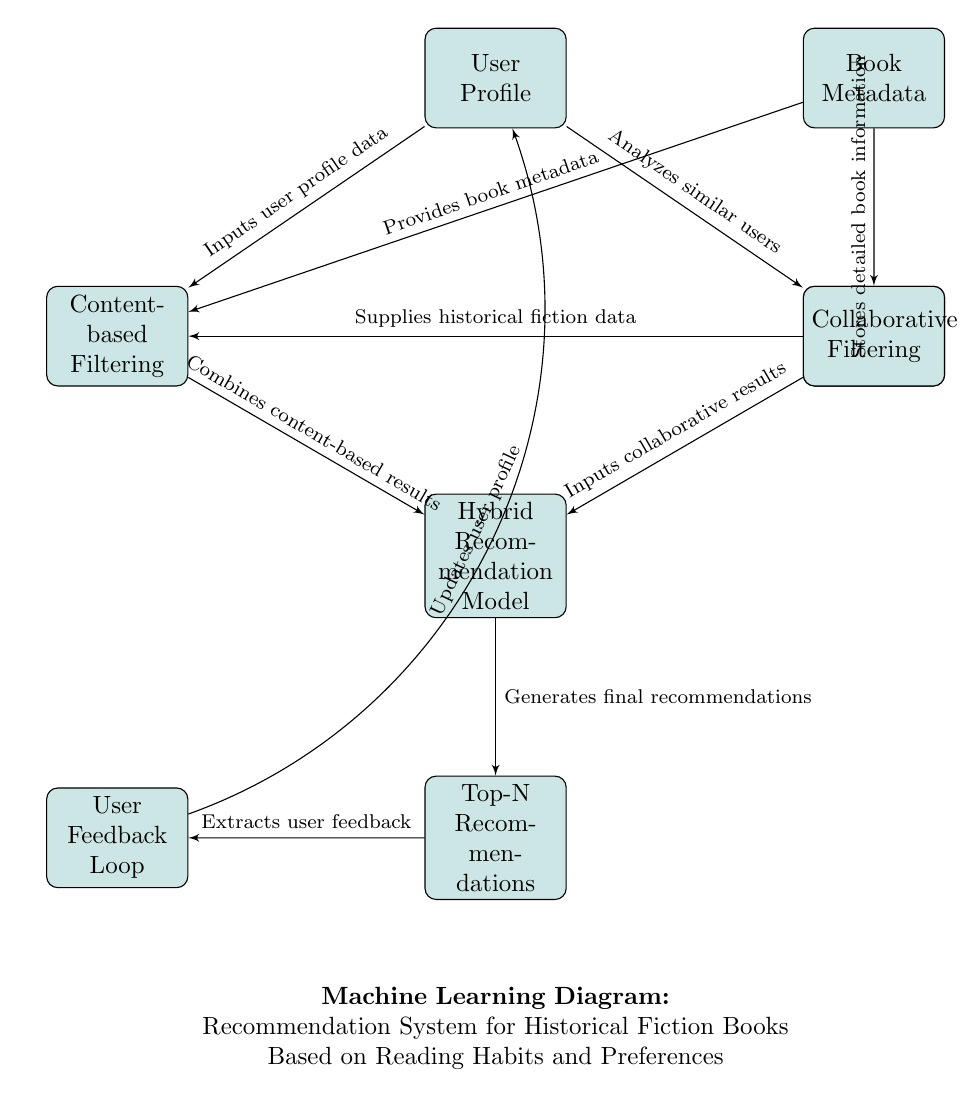What is the first node in the diagram? The first node is labeled "User Profile," indicating where the system begins by taking user-related information as input.
Answer: User Profile How many nodes are there in total? By counting all the distinct blocks in the diagram, we can see there are 7 nodes: User Profile, Book Metadata, Historical Fiction Database, Content-based Filtering, Collaborative Filtering, Hybrid Recommendation Model, and Top-N Recommendations.
Answer: 7 What does the "Hybrid Recommendation Model" node receive as input? The "Hybrid Recommendation Model" node receives inputs from both the "Content-based Filtering" and "Collaborative Filtering" nodes, which provide combined results based on different recommendation strategies.
Answer: Collaborative results and content-based results Which node provides book metadata? The node labeled "Book Metadata" is responsible for providing the necessary metadata for the books in the system, which other components use for analysis and filtering.
Answer: Book Metadata What happens after "Top-N Recommendations"? After "Top-N Recommendations," the user feedback is extracted to help refine the system further, creating a feedback loop that influences future recommendations.
Answer: User Feedback Loop Which nodes connect to the "Hybrid Recommendation Model"? The nodes that connect to the "Hybrid Recommendation Model" are "Content-based Filtering" and "Collaborative Filtering," both of which feed their results into the hybrid model to generate final recommendations.
Answer: Content-based Filtering and Collaborative Filtering How does the "User Feedback Loop" affect the "User Profile"? The "User Feedback Loop" updates the "User Profile" based on the extracted feedback, ensuring the recommendations improve over time by tailoring future suggestions to user preferences.
Answer: Updates user profile What is the role of the "Historical Fiction Database"? The "Historical Fiction Database" supplies historical fiction data to the "Content-based Filtering" node and stores detailed book information for better analysis and filtering.
Answer: Supplies historical fiction data What type of filtering is used in the system? The system employs both content-based filtering and collaborative filtering as methods for generating book recommendations, allowing for a more comprehensive approach to suggestions.
Answer: Content-based Filtering and Collaborative Filtering 